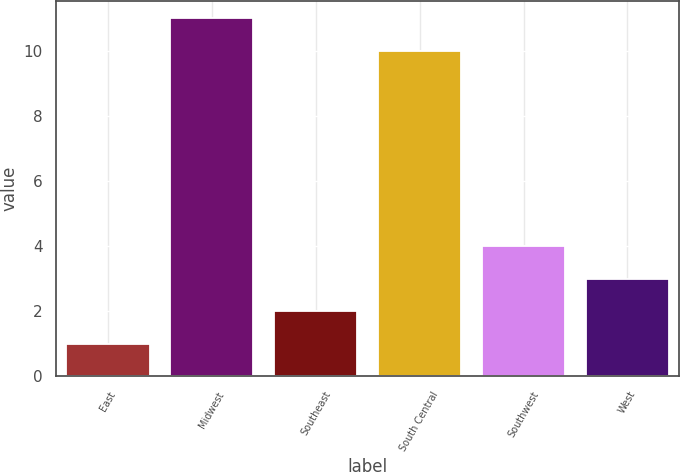Convert chart. <chart><loc_0><loc_0><loc_500><loc_500><bar_chart><fcel>East<fcel>Midwest<fcel>Southeast<fcel>South Central<fcel>Southwest<fcel>West<nl><fcel>1<fcel>11<fcel>2<fcel>10<fcel>4<fcel>3<nl></chart> 